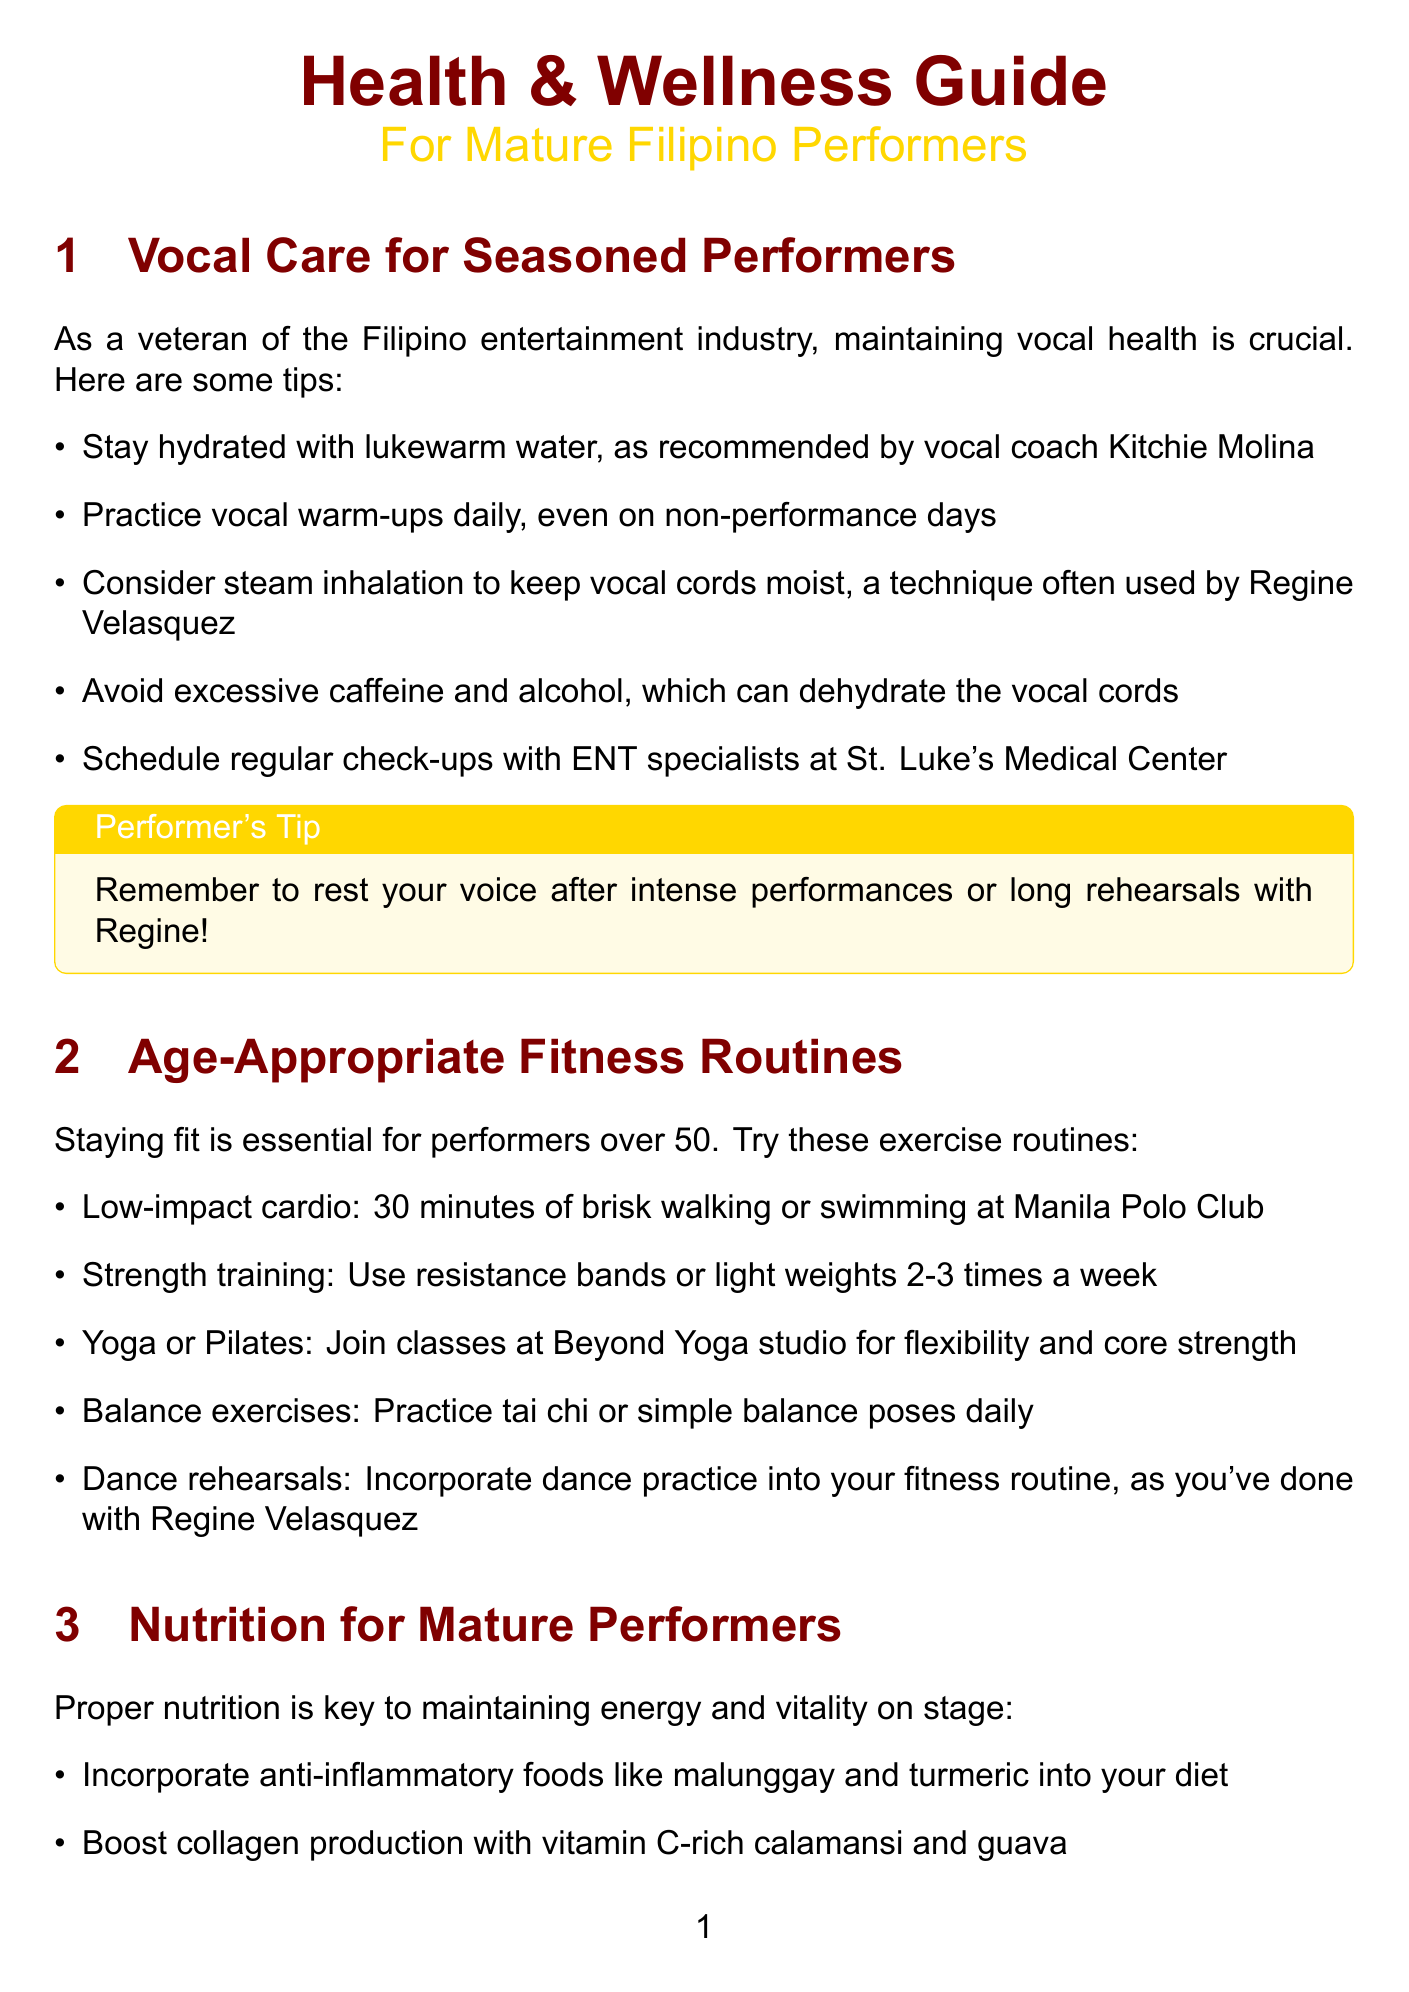what is one recommended method for maintaining vocal health? The document lists several methods for vocal health, including steam inhalation to keep vocal cords moist.
Answer: steam inhalation how often should strength training be done according to the fitness routines? The newsletter advises doing strength training 2-3 times a week.
Answer: 2-3 times a week who provides personalized meal plans for performers? The document mentions consulting with nutritionist Cheshire Que for personalized meal plans.
Answer: Cheshire Que what type of exercise is suggested for balance? The newsletter recommends practicing tai chi or simple balance poses for balance.
Answer: tai chi or simple balance poses which skincare product is advised for UV protection? The document suggests using sunscreen daily, specifically Belo SunExpert, for UV protection.
Answer: Belo SunExpert how many minutes of daily mindfulness meditation are recommended? The document states that 10 minutes of mindfulness meditation should be practiced daily.
Answer: 10 minutes what is a common anti-inflammatory food mentioned in the nutrition section? The document mentions malunggay as an anti-inflammatory food recommended in the nutrition section.
Answer: malunggay what is one of the hobbies suggested for mental wellness? The newsletter suggests engaging in hobbies like painting or gardening for mental wellness.
Answer: painting or gardening which dermatologist is referenced for anti-aging skincare advice? The document references dermatologist Dr. Vicki Belo for anti-aging skincare advice.
Answer: Dr. Vicki Belo 